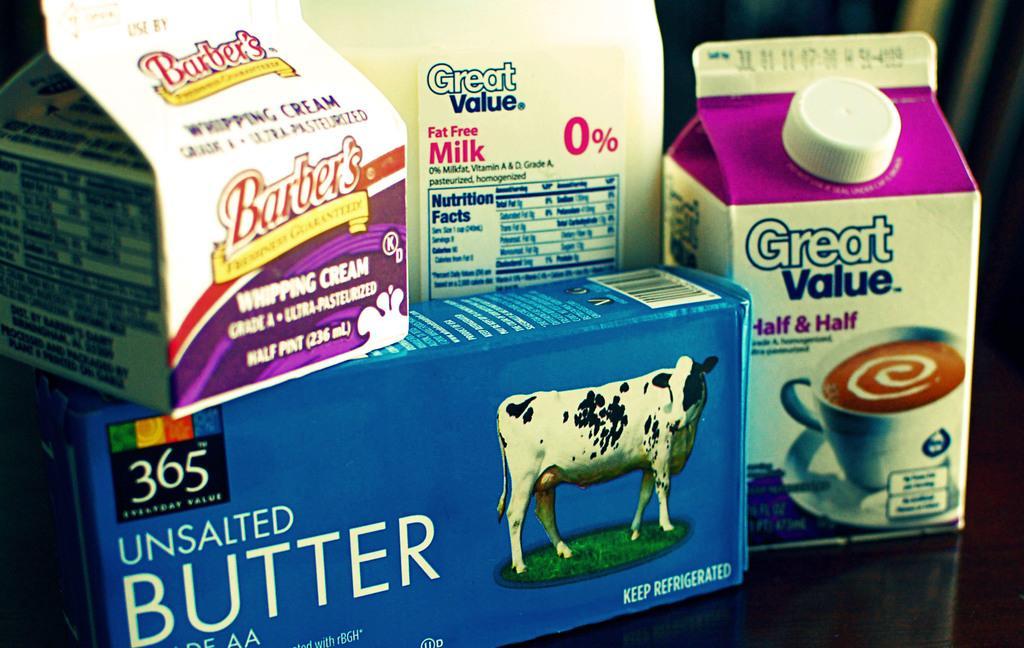Can you describe this image briefly? In this image we can see some tetra milk packets which are placed on the surface. 